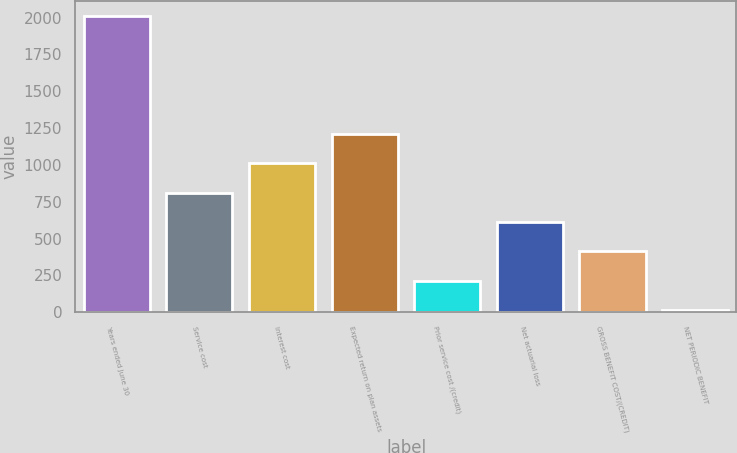<chart> <loc_0><loc_0><loc_500><loc_500><bar_chart><fcel>Years ended June 30<fcel>Service cost<fcel>Interest cost<fcel>Expected return on plan assets<fcel>Prior service cost /(credit)<fcel>Net actuarial loss<fcel>GROSS BENEFIT COST/(CREDIT)<fcel>NET PERIODIC BENEFIT<nl><fcel>2011<fcel>812.2<fcel>1012<fcel>1211.8<fcel>212.8<fcel>612.4<fcel>412.6<fcel>13<nl></chart> 